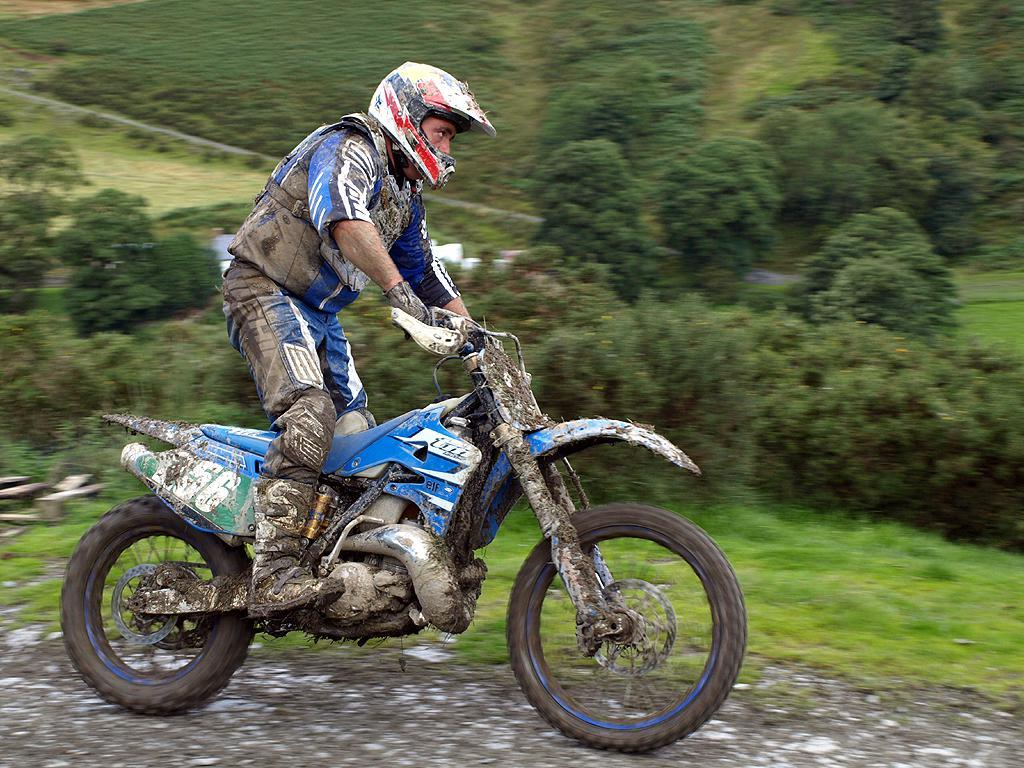What is the person in the image doing? There is a person riding a bike in the image. What type of vegetation can be seen in the image? There are plants, trees, and grass in the image. What type of fog can be seen in the bedroom in the image? There is no bedroom or fog present in the image; it features a person riding a bike and various types of vegetation. 